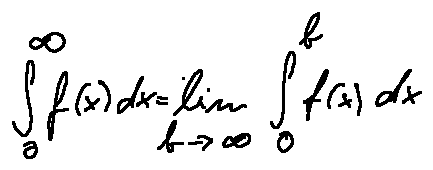<formula> <loc_0><loc_0><loc_500><loc_500>\int \lim i t s _ { 0 } ^ { \infty } f ( x ) d x = \lim \lim i t s _ { b \rightarrow \infty } \int \lim i t s _ { 0 } ^ { b } f ( x ) d x</formula> 